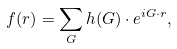Convert formula to latex. <formula><loc_0><loc_0><loc_500><loc_500>f ( r ) = \sum _ { G } h ( G ) \cdot e ^ { i G \cdot r } ,</formula> 